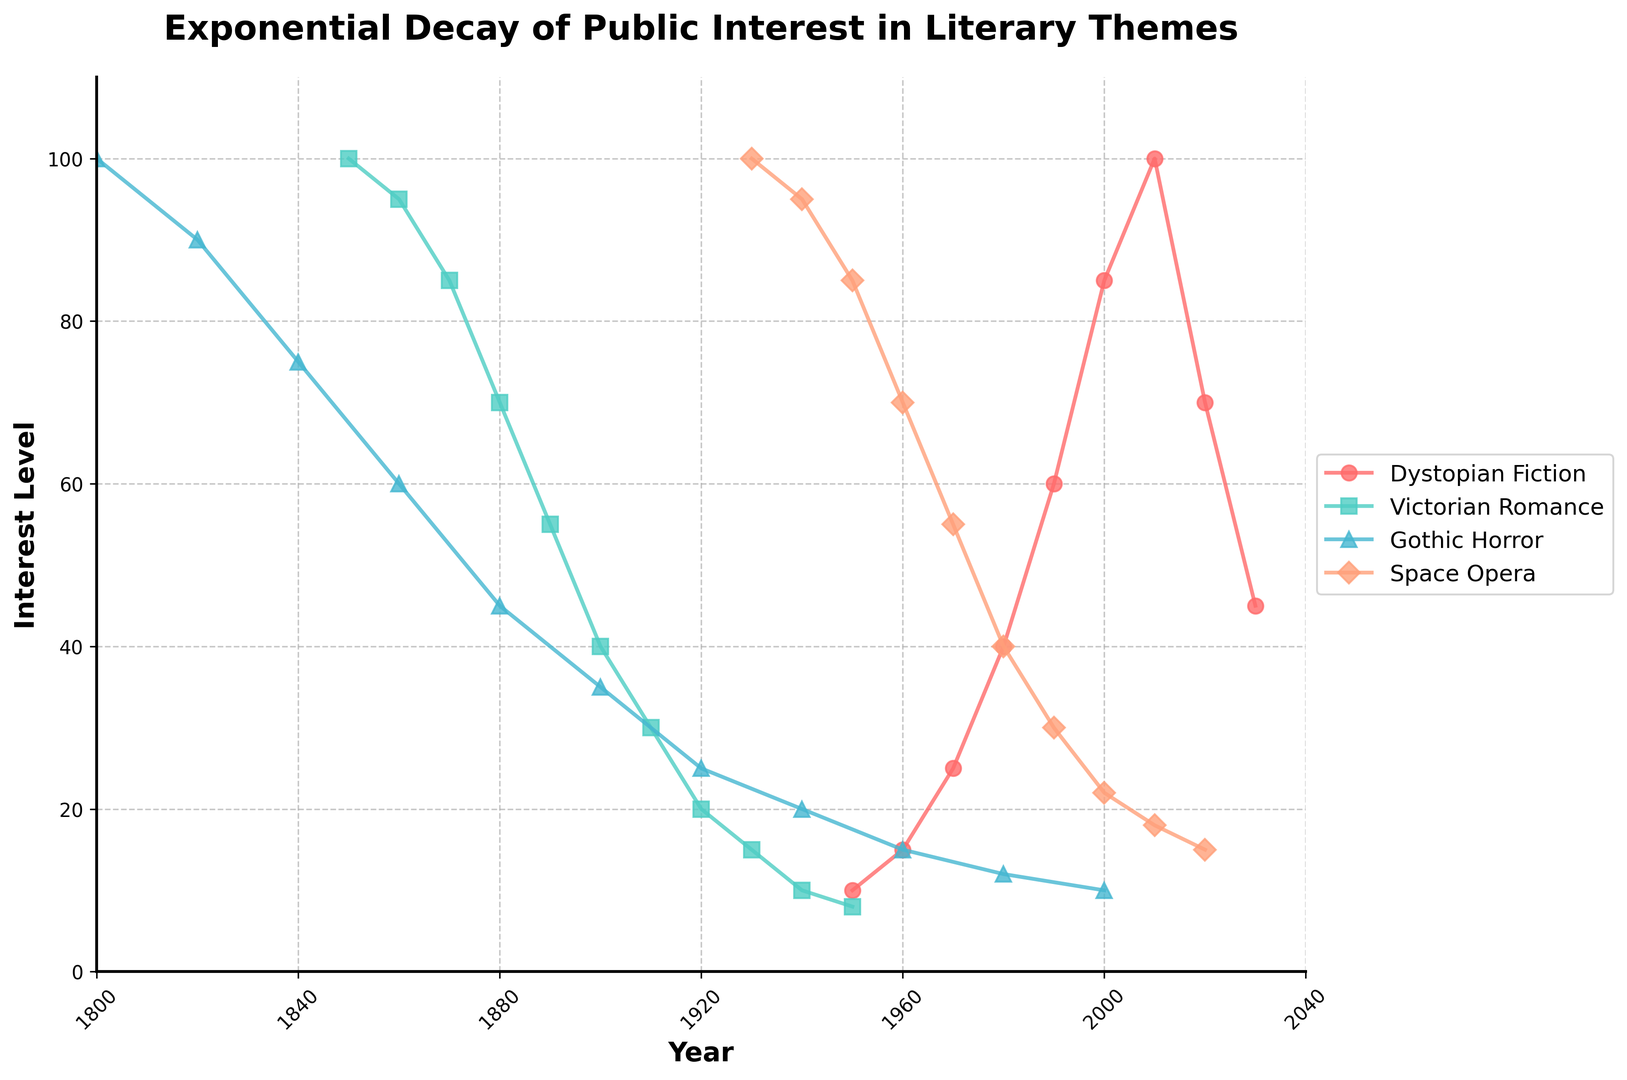What's the trend of interest level for "Dystopian Fiction" from the 1950s to the 2030s? The interest level in "Dystopian Fiction" increases from 1950 to 2010, peaking in 2010, and then decreases towards 2030. Specifically, it rises from 10 in 1950 to 100 in 2010, then dips to 70 in 2020 and further to 45 in 2030.
Answer: Rising then falling Which theme had the highest interest level in the 1800s? By observing the plot, "Gothic Horror" has the highest interest level at 100 in the 1800s, while "Victorian Romance" has lower values starting at 100 in 1850.
Answer: Gothic Horror Compare the decline rate of interest level in Victorian Romance between 1850 and 1900 with that of Space Opera between 1930 and 1980. Victorian Romance declined from 100 in 1850 to 40 in 1900, a 60-point decrease over 50 years. Space Opera declined from 100 in 1930 to 40 in 1980, also a 60-point decrease over 50 years. Both themes had similar decline rates over their respective periods.
Answer: Similar decline rates What was the interest level in "Gothic Horror" in 1900, and how does it compare to "Victorian Romance" in the same year? In 1900, the interest level for "Gothic Horror" was 35, while for "Victorian Romance," it was 40. Thus, "Victorian Romance" had a slightly higher interest level than "Gothic Horror" in 1900.
Answer: Victorian Romance had higher interest Identify the decade where "Dystopian Fiction" had the highest interest level and compare it to the highest level of "Space Opera." "Dystopian Fiction" had the highest interest level in the 2010s with a value of 100. The highest interest level in "Space Opera" was 100 in the 1930s, matching the peak of "Dystopian Fiction" but at different times.
Answer: Both at 100 How did the interest level for "Victorian Romance" change between 1850 and 1950, and what does this indicate? The interest level for "Victorian Romance" decreased steadily from 100 in 1850 to 8 in 1950, indicating a long-term decline in public interest over this century.
Answer: Long-term decline What is the average interest level for "Gothic Horror" throughout the plotted time frame? Sum the interest levels from each plotted year for "Gothic Horror" (100 + 90 + 75 + 60 + 45 + 35 + 25 + 20 + 15 + 12 + 10 = 487) and divide by the number of data points (11), resulting in the average: 487 / 11 ≈ 44.27.
Answer: 44.27 From the figure, during which period did "Space Opera" experience the steepest decline in interest level? "Space Opera" experienced the steepest decline during the period from 1930 to 1980, where the interest level dropped from 100 to 40, indicating a 60-point decline over 50 years.
Answer: 1930-1980 What color represents "Victorian Romance"? Observing the figure, "Victorian Romance" is represented by the color green, as indicated by its distinctive line color in the plot.
Answer: Green How does the interest level change for "Dystopian Fiction" from 2010 to 2030, and what might this indicate about its future trend? The interest level for "Dystopian Fiction" decreases from 100 in 2010 to 45 in 2030, falling by 55 points. This decline indicates a possible waning interest in the theme post-2010.
Answer: Declining trend 